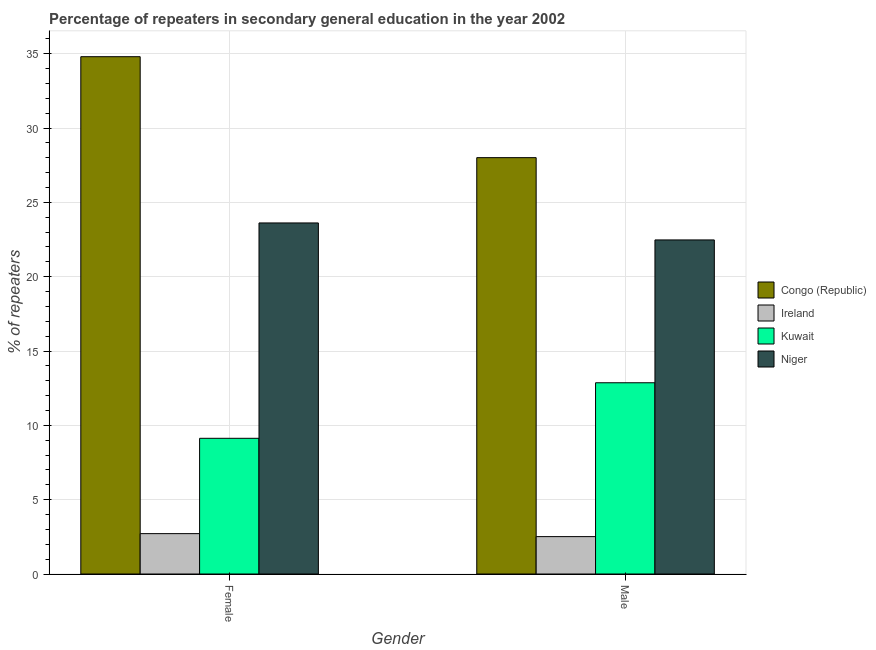How many groups of bars are there?
Your answer should be compact. 2. Are the number of bars on each tick of the X-axis equal?
Offer a very short reply. Yes. How many bars are there on the 2nd tick from the right?
Provide a short and direct response. 4. What is the label of the 1st group of bars from the left?
Give a very brief answer. Female. What is the percentage of male repeaters in Ireland?
Your response must be concise. 2.51. Across all countries, what is the maximum percentage of female repeaters?
Offer a terse response. 34.8. Across all countries, what is the minimum percentage of female repeaters?
Give a very brief answer. 2.72. In which country was the percentage of female repeaters maximum?
Your answer should be very brief. Congo (Republic). In which country was the percentage of male repeaters minimum?
Give a very brief answer. Ireland. What is the total percentage of female repeaters in the graph?
Make the answer very short. 70.26. What is the difference between the percentage of female repeaters in Kuwait and that in Niger?
Your answer should be compact. -14.49. What is the difference between the percentage of male repeaters in Congo (Republic) and the percentage of female repeaters in Ireland?
Your answer should be compact. 25.29. What is the average percentage of male repeaters per country?
Make the answer very short. 16.47. What is the difference between the percentage of male repeaters and percentage of female repeaters in Ireland?
Keep it short and to the point. -0.2. In how many countries, is the percentage of female repeaters greater than 29 %?
Offer a very short reply. 1. What is the ratio of the percentage of male repeaters in Congo (Republic) to that in Ireland?
Your answer should be compact. 11.14. What does the 4th bar from the left in Male represents?
Your answer should be compact. Niger. What does the 1st bar from the right in Female represents?
Ensure brevity in your answer.  Niger. How many countries are there in the graph?
Your response must be concise. 4. What is the difference between two consecutive major ticks on the Y-axis?
Your response must be concise. 5. Are the values on the major ticks of Y-axis written in scientific E-notation?
Provide a short and direct response. No. Does the graph contain any zero values?
Make the answer very short. No. How many legend labels are there?
Provide a succinct answer. 4. How are the legend labels stacked?
Make the answer very short. Vertical. What is the title of the graph?
Your response must be concise. Percentage of repeaters in secondary general education in the year 2002. Does "Chile" appear as one of the legend labels in the graph?
Make the answer very short. No. What is the label or title of the X-axis?
Your answer should be compact. Gender. What is the label or title of the Y-axis?
Ensure brevity in your answer.  % of repeaters. What is the % of repeaters of Congo (Republic) in Female?
Keep it short and to the point. 34.8. What is the % of repeaters of Ireland in Female?
Offer a terse response. 2.72. What is the % of repeaters of Kuwait in Female?
Keep it short and to the point. 9.13. What is the % of repeaters of Niger in Female?
Your response must be concise. 23.62. What is the % of repeaters of Congo (Republic) in Male?
Keep it short and to the point. 28.01. What is the % of repeaters of Ireland in Male?
Keep it short and to the point. 2.51. What is the % of repeaters in Kuwait in Male?
Your answer should be very brief. 12.87. What is the % of repeaters of Niger in Male?
Your response must be concise. 22.47. Across all Gender, what is the maximum % of repeaters in Congo (Republic)?
Offer a very short reply. 34.8. Across all Gender, what is the maximum % of repeaters of Ireland?
Provide a short and direct response. 2.72. Across all Gender, what is the maximum % of repeaters of Kuwait?
Provide a short and direct response. 12.87. Across all Gender, what is the maximum % of repeaters in Niger?
Your response must be concise. 23.62. Across all Gender, what is the minimum % of repeaters of Congo (Republic)?
Your answer should be compact. 28.01. Across all Gender, what is the minimum % of repeaters of Ireland?
Keep it short and to the point. 2.51. Across all Gender, what is the minimum % of repeaters of Kuwait?
Keep it short and to the point. 9.13. Across all Gender, what is the minimum % of repeaters of Niger?
Your answer should be compact. 22.47. What is the total % of repeaters of Congo (Republic) in the graph?
Offer a very short reply. 62.81. What is the total % of repeaters of Ireland in the graph?
Provide a short and direct response. 5.23. What is the total % of repeaters in Kuwait in the graph?
Provide a succinct answer. 21.99. What is the total % of repeaters in Niger in the graph?
Your answer should be very brief. 46.09. What is the difference between the % of repeaters in Congo (Republic) in Female and that in Male?
Provide a short and direct response. 6.79. What is the difference between the % of repeaters in Ireland in Female and that in Male?
Keep it short and to the point. 0.2. What is the difference between the % of repeaters in Kuwait in Female and that in Male?
Keep it short and to the point. -3.74. What is the difference between the % of repeaters of Niger in Female and that in Male?
Offer a terse response. 1.14. What is the difference between the % of repeaters in Congo (Republic) in Female and the % of repeaters in Ireland in Male?
Provide a succinct answer. 32.29. What is the difference between the % of repeaters in Congo (Republic) in Female and the % of repeaters in Kuwait in Male?
Provide a short and direct response. 21.93. What is the difference between the % of repeaters of Congo (Republic) in Female and the % of repeaters of Niger in Male?
Ensure brevity in your answer.  12.33. What is the difference between the % of repeaters in Ireland in Female and the % of repeaters in Kuwait in Male?
Give a very brief answer. -10.15. What is the difference between the % of repeaters of Ireland in Female and the % of repeaters of Niger in Male?
Your answer should be very brief. -19.76. What is the difference between the % of repeaters of Kuwait in Female and the % of repeaters of Niger in Male?
Ensure brevity in your answer.  -13.34. What is the average % of repeaters in Congo (Republic) per Gender?
Ensure brevity in your answer.  31.4. What is the average % of repeaters in Ireland per Gender?
Offer a terse response. 2.62. What is the average % of repeaters of Kuwait per Gender?
Give a very brief answer. 11. What is the average % of repeaters in Niger per Gender?
Provide a short and direct response. 23.04. What is the difference between the % of repeaters in Congo (Republic) and % of repeaters in Ireland in Female?
Give a very brief answer. 32.08. What is the difference between the % of repeaters of Congo (Republic) and % of repeaters of Kuwait in Female?
Provide a short and direct response. 25.67. What is the difference between the % of repeaters in Congo (Republic) and % of repeaters in Niger in Female?
Your response must be concise. 11.18. What is the difference between the % of repeaters of Ireland and % of repeaters of Kuwait in Female?
Provide a succinct answer. -6.41. What is the difference between the % of repeaters in Ireland and % of repeaters in Niger in Female?
Offer a terse response. -20.9. What is the difference between the % of repeaters of Kuwait and % of repeaters of Niger in Female?
Your answer should be very brief. -14.49. What is the difference between the % of repeaters in Congo (Republic) and % of repeaters in Ireland in Male?
Your answer should be compact. 25.49. What is the difference between the % of repeaters of Congo (Republic) and % of repeaters of Kuwait in Male?
Provide a short and direct response. 15.14. What is the difference between the % of repeaters in Congo (Republic) and % of repeaters in Niger in Male?
Ensure brevity in your answer.  5.54. What is the difference between the % of repeaters of Ireland and % of repeaters of Kuwait in Male?
Offer a very short reply. -10.35. What is the difference between the % of repeaters of Ireland and % of repeaters of Niger in Male?
Keep it short and to the point. -19.96. What is the difference between the % of repeaters of Kuwait and % of repeaters of Niger in Male?
Provide a succinct answer. -9.61. What is the ratio of the % of repeaters in Congo (Republic) in Female to that in Male?
Give a very brief answer. 1.24. What is the ratio of the % of repeaters of Ireland in Female to that in Male?
Keep it short and to the point. 1.08. What is the ratio of the % of repeaters in Kuwait in Female to that in Male?
Make the answer very short. 0.71. What is the ratio of the % of repeaters in Niger in Female to that in Male?
Provide a succinct answer. 1.05. What is the difference between the highest and the second highest % of repeaters of Congo (Republic)?
Give a very brief answer. 6.79. What is the difference between the highest and the second highest % of repeaters in Ireland?
Provide a short and direct response. 0.2. What is the difference between the highest and the second highest % of repeaters in Kuwait?
Give a very brief answer. 3.74. What is the difference between the highest and the second highest % of repeaters of Niger?
Make the answer very short. 1.14. What is the difference between the highest and the lowest % of repeaters in Congo (Republic)?
Make the answer very short. 6.79. What is the difference between the highest and the lowest % of repeaters in Ireland?
Your answer should be very brief. 0.2. What is the difference between the highest and the lowest % of repeaters of Kuwait?
Provide a succinct answer. 3.74. What is the difference between the highest and the lowest % of repeaters in Niger?
Offer a very short reply. 1.14. 